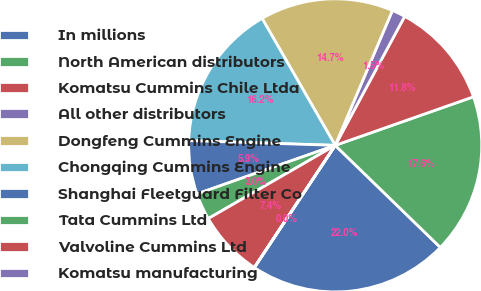Convert chart to OTSL. <chart><loc_0><loc_0><loc_500><loc_500><pie_chart><fcel>In millions<fcel>North American distributors<fcel>Komatsu Cummins Chile Ltda<fcel>All other distributors<fcel>Dongfeng Cummins Engine<fcel>Chongqing Cummins Engine<fcel>Shanghai Fleetguard Filter Co<fcel>Tata Cummins Ltd<fcel>Valvoline Cummins Ltd<fcel>Komatsu manufacturing<nl><fcel>22.04%<fcel>17.64%<fcel>11.76%<fcel>1.48%<fcel>14.7%<fcel>16.17%<fcel>5.89%<fcel>2.95%<fcel>7.36%<fcel>0.01%<nl></chart> 